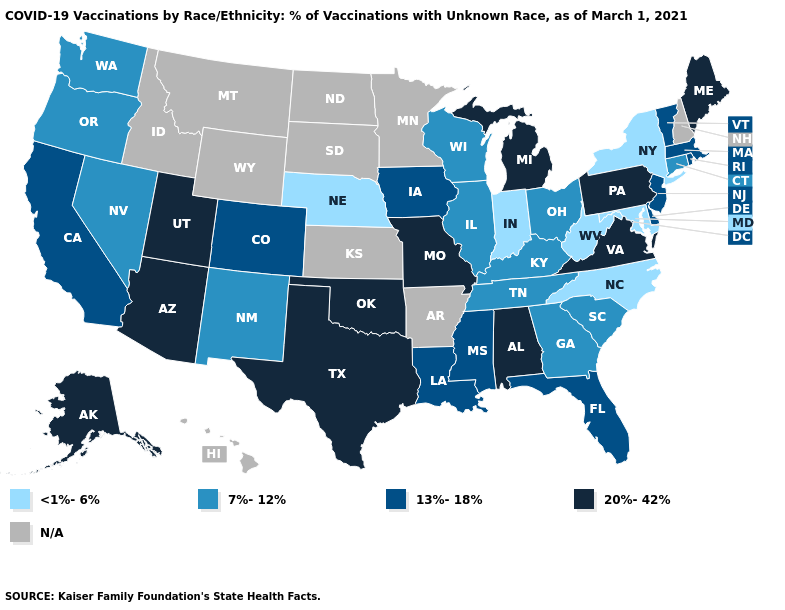What is the value of New Hampshire?
Answer briefly. N/A. What is the lowest value in the MidWest?
Keep it brief. <1%-6%. What is the value of Minnesota?
Short answer required. N/A. Among the states that border Vermont , which have the highest value?
Concise answer only. Massachusetts. Does Illinois have the lowest value in the USA?
Short answer required. No. Name the states that have a value in the range 13%-18%?
Be succinct. California, Colorado, Delaware, Florida, Iowa, Louisiana, Massachusetts, Mississippi, New Jersey, Rhode Island, Vermont. Is the legend a continuous bar?
Answer briefly. No. What is the value of Maine?
Give a very brief answer. 20%-42%. Name the states that have a value in the range N/A?
Keep it brief. Arkansas, Hawaii, Idaho, Kansas, Minnesota, Montana, New Hampshire, North Dakota, South Dakota, Wyoming. Name the states that have a value in the range 13%-18%?
Quick response, please. California, Colorado, Delaware, Florida, Iowa, Louisiana, Massachusetts, Mississippi, New Jersey, Rhode Island, Vermont. Name the states that have a value in the range 13%-18%?
Short answer required. California, Colorado, Delaware, Florida, Iowa, Louisiana, Massachusetts, Mississippi, New Jersey, Rhode Island, Vermont. Name the states that have a value in the range 20%-42%?
Quick response, please. Alabama, Alaska, Arizona, Maine, Michigan, Missouri, Oklahoma, Pennsylvania, Texas, Utah, Virginia. What is the lowest value in states that border Kentucky?
Give a very brief answer. <1%-6%. What is the highest value in states that border Colorado?
Answer briefly. 20%-42%. Which states hav the highest value in the MidWest?
Quick response, please. Michigan, Missouri. 